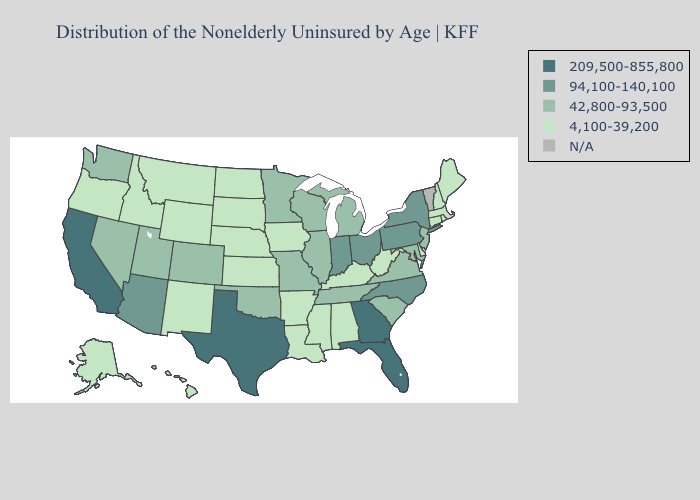What is the value of Arkansas?
Short answer required. 4,100-39,200. Name the states that have a value in the range 94,100-140,100?
Write a very short answer. Arizona, Indiana, New York, North Carolina, Ohio, Pennsylvania. What is the highest value in the MidWest ?
Give a very brief answer. 94,100-140,100. Does Minnesota have the lowest value in the USA?
Give a very brief answer. No. Among the states that border Louisiana , which have the lowest value?
Concise answer only. Arkansas, Mississippi. Name the states that have a value in the range 42,800-93,500?
Short answer required. Colorado, Illinois, Maryland, Michigan, Minnesota, Missouri, Nevada, New Jersey, Oklahoma, South Carolina, Tennessee, Utah, Virginia, Washington, Wisconsin. Which states have the lowest value in the West?
Answer briefly. Alaska, Hawaii, Idaho, Montana, New Mexico, Oregon, Wyoming. What is the value of North Carolina?
Be succinct. 94,100-140,100. What is the value of Louisiana?
Give a very brief answer. 4,100-39,200. Does Kansas have the lowest value in the MidWest?
Give a very brief answer. Yes. What is the highest value in states that border Kentucky?
Keep it brief. 94,100-140,100. Among the states that border Pennsylvania , which have the lowest value?
Concise answer only. Delaware, West Virginia. Which states have the highest value in the USA?
Answer briefly. California, Florida, Georgia, Texas. Does Florida have the lowest value in the South?
Quick response, please. No. What is the highest value in the USA?
Give a very brief answer. 209,500-855,800. 